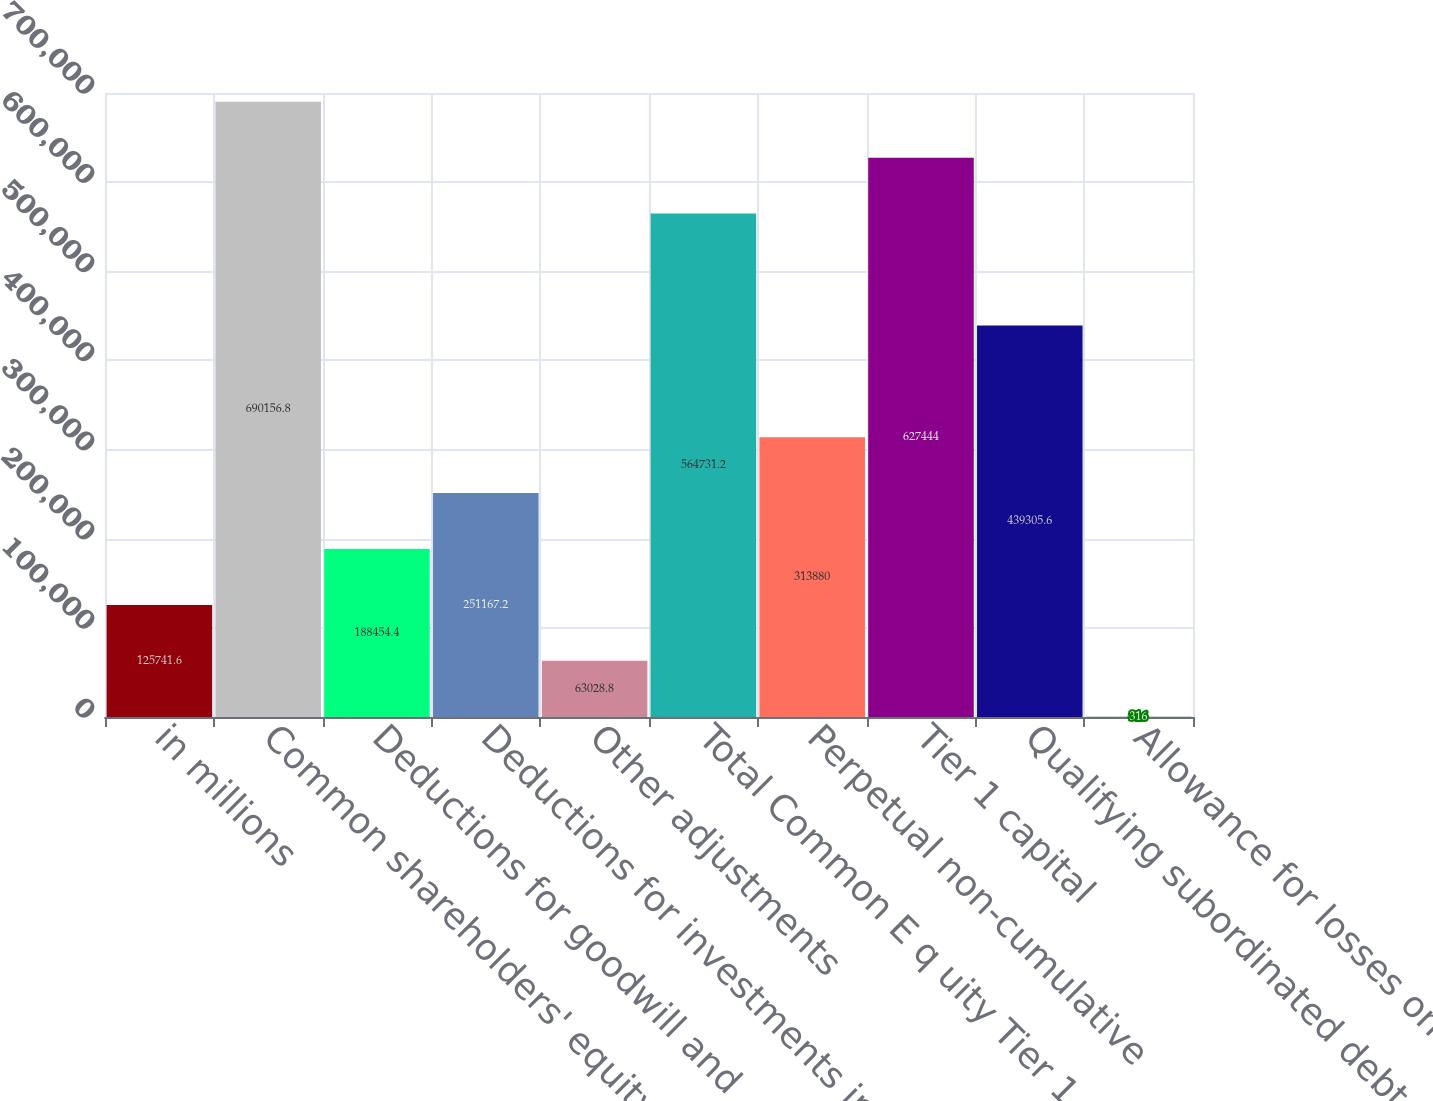Convert chart to OTSL. <chart><loc_0><loc_0><loc_500><loc_500><bar_chart><fcel>in millions<fcel>Common shareholders' equity<fcel>Deductions for goodwill and<fcel>Deductions for investments in<fcel>Other adjustments<fcel>Total Common E q uity Tier 1<fcel>Perpetual non-cumulative<fcel>Tier 1 capital<fcel>Qualifying subordinated debt<fcel>Allowance for losses on loans<nl><fcel>125742<fcel>690157<fcel>188454<fcel>251167<fcel>63028.8<fcel>564731<fcel>313880<fcel>627444<fcel>439306<fcel>316<nl></chart> 